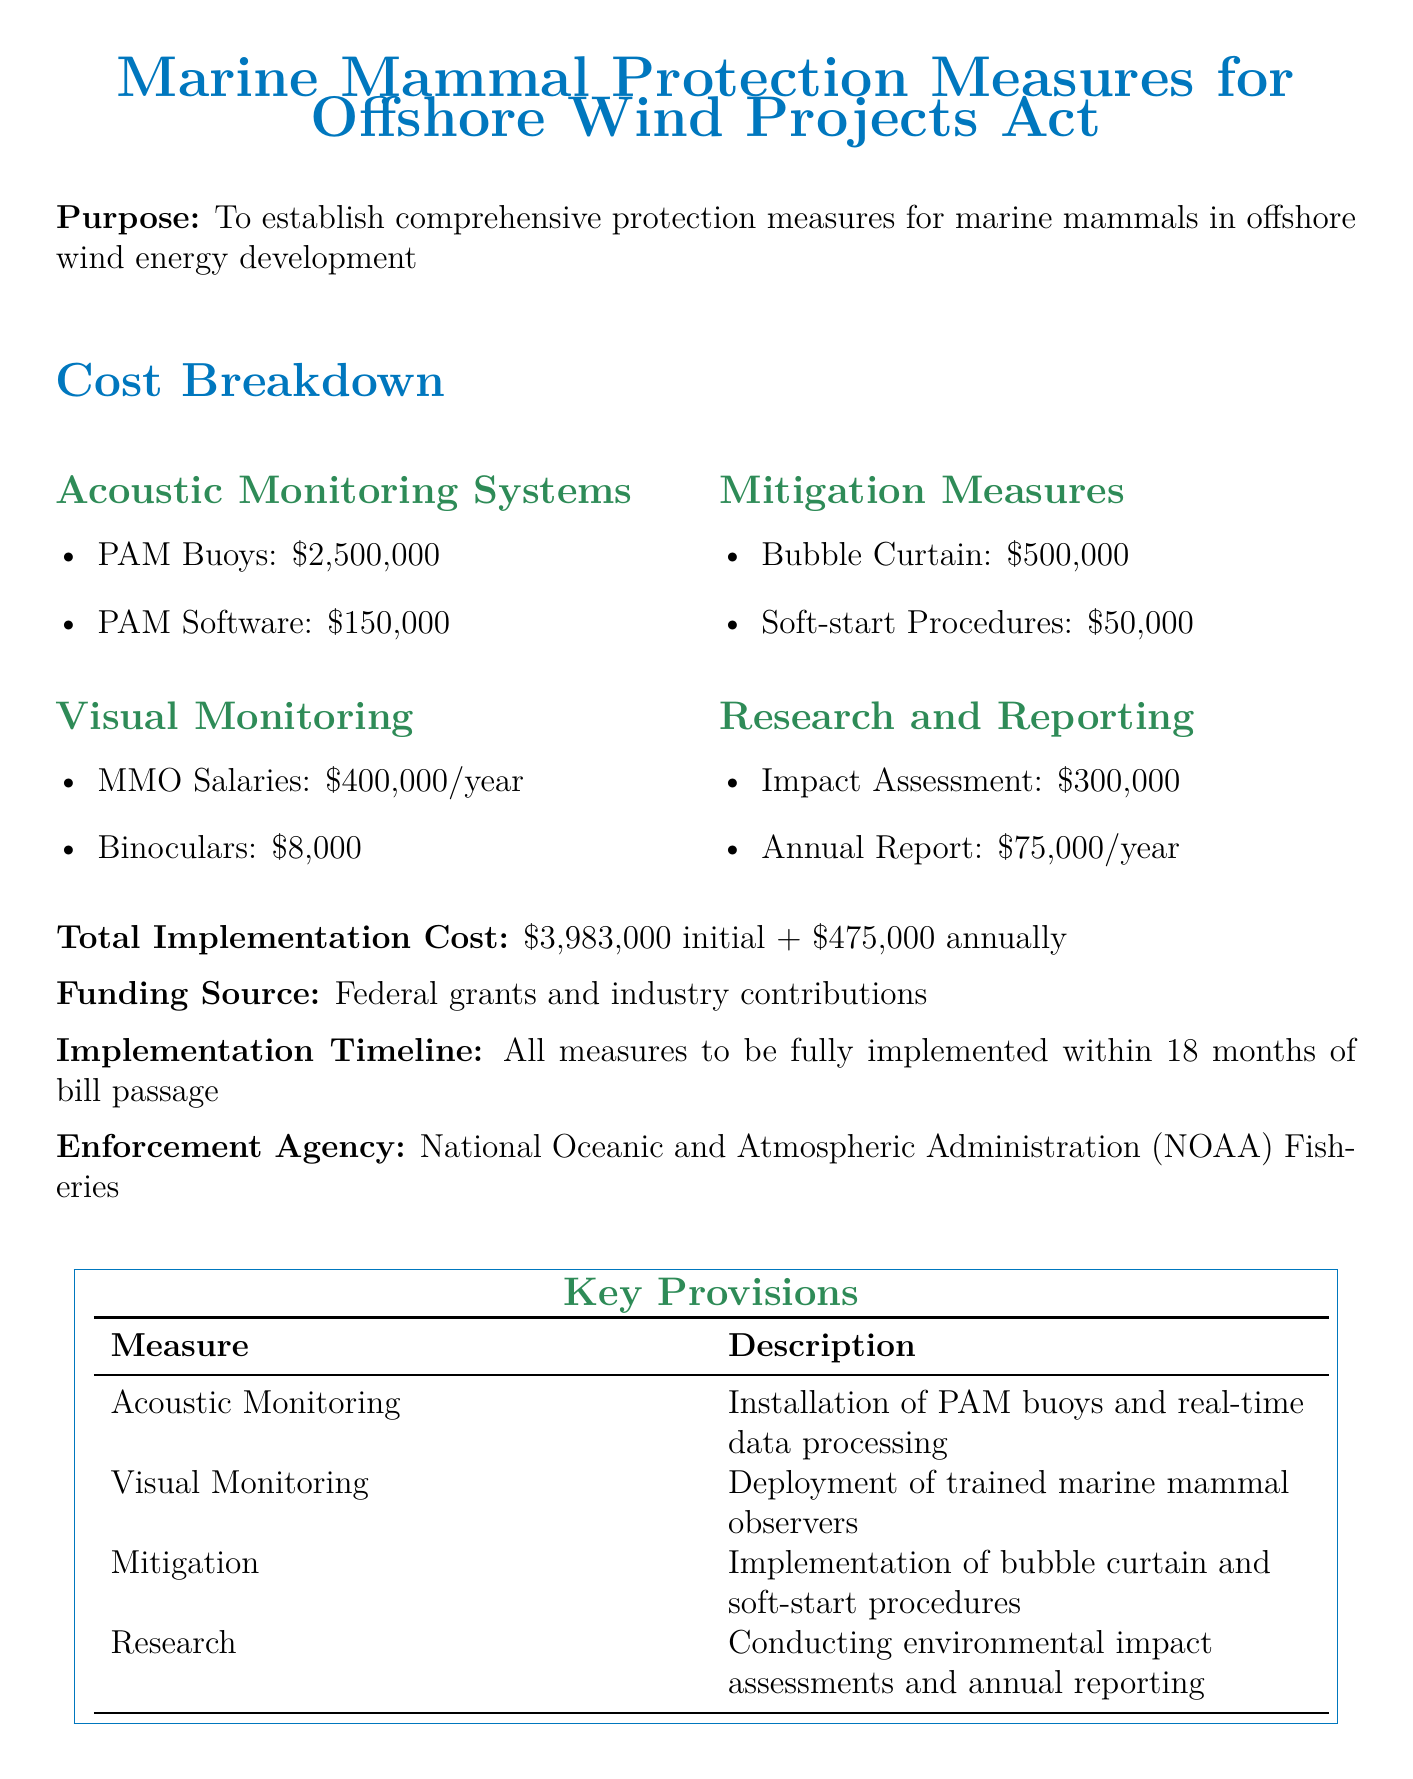What is the total implementation cost? The total implementation cost is explicitly mentioned in the document.
Answer: $3,983,000 initial + $475,000 annually Who enforces the marine mammal protection measures? The document specifies the enforcement agency responsible for these measures.
Answer: National Oceanic and Atmospheric Administration (NOAA) Fisheries What is the cost of PAM buoys? The cost of PAM buoys is listed under Acoustic Monitoring Systems in the document.
Answer: $2,500,000 How long is the implementation timeline? The timeline for implementation is stated in the document, indicating how soon the measures will be in place.
Answer: 18 months What is the annual cost for MMO salaries? The salary cost for marine mammal observers is given under Visual Monitoring.
Answer: $400,000/year What is the funding source for the project? The document mentions the specific sources of funding for implementing the measures.
Answer: Federal grants and industry contributions What mitigation measure costs $500,000? The document lists various mitigation measures along with their costs.
Answer: Bubble Curtain What is the cost of the annual report? The cost for the annual report is found in the Research and Reporting section.
Answer: $75,000/year What is the purpose of the bill? The purpose of the bill is stated clearly at the beginning of the document.
Answer: To establish comprehensive protection measures for marine mammals in offshore wind energy development 